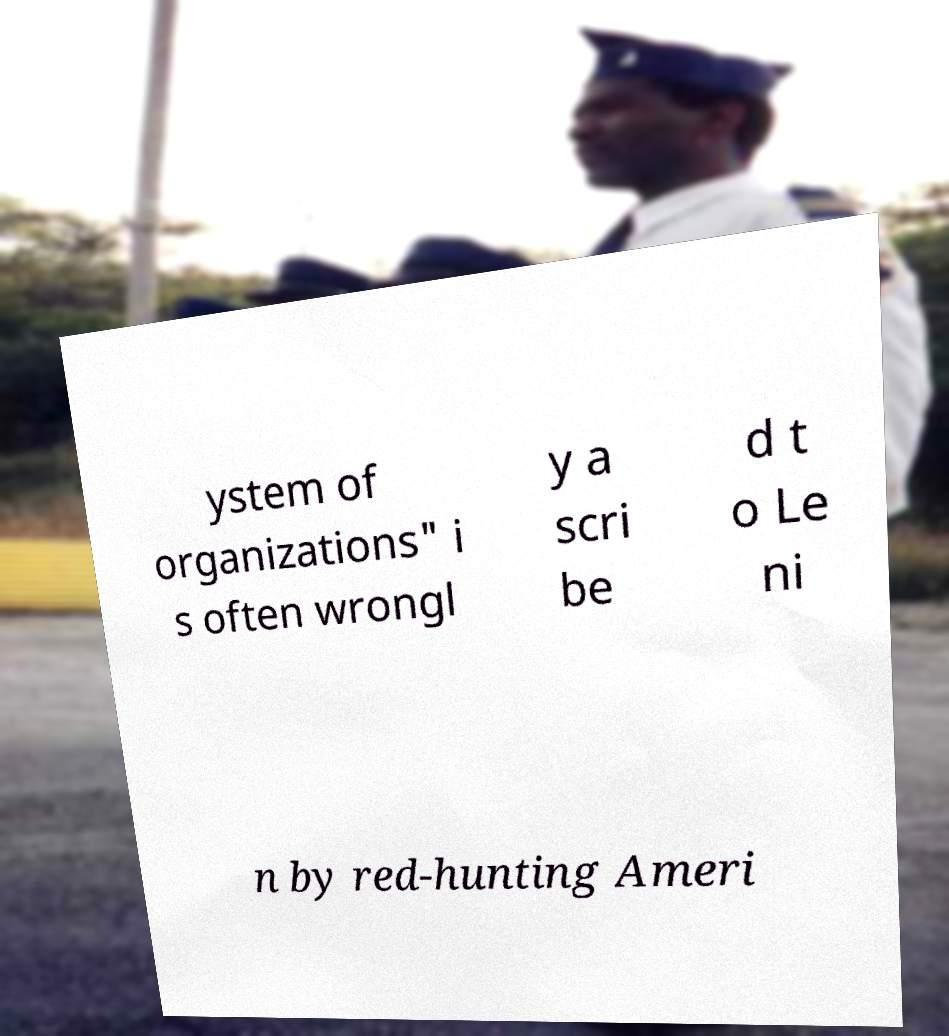Please identify and transcribe the text found in this image. ystem of organizations" i s often wrongl y a scri be d t o Le ni n by red-hunting Ameri 